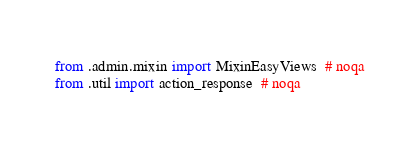Convert code to text. <code><loc_0><loc_0><loc_500><loc_500><_Python_>from .admin.mixin import MixinEasyViews  # noqa
from .util import action_response  # noqa
</code> 